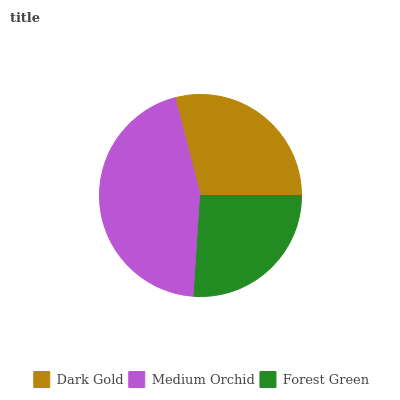Is Forest Green the minimum?
Answer yes or no. Yes. Is Medium Orchid the maximum?
Answer yes or no. Yes. Is Medium Orchid the minimum?
Answer yes or no. No. Is Forest Green the maximum?
Answer yes or no. No. Is Medium Orchid greater than Forest Green?
Answer yes or no. Yes. Is Forest Green less than Medium Orchid?
Answer yes or no. Yes. Is Forest Green greater than Medium Orchid?
Answer yes or no. No. Is Medium Orchid less than Forest Green?
Answer yes or no. No. Is Dark Gold the high median?
Answer yes or no. Yes. Is Dark Gold the low median?
Answer yes or no. Yes. Is Medium Orchid the high median?
Answer yes or no. No. Is Forest Green the low median?
Answer yes or no. No. 